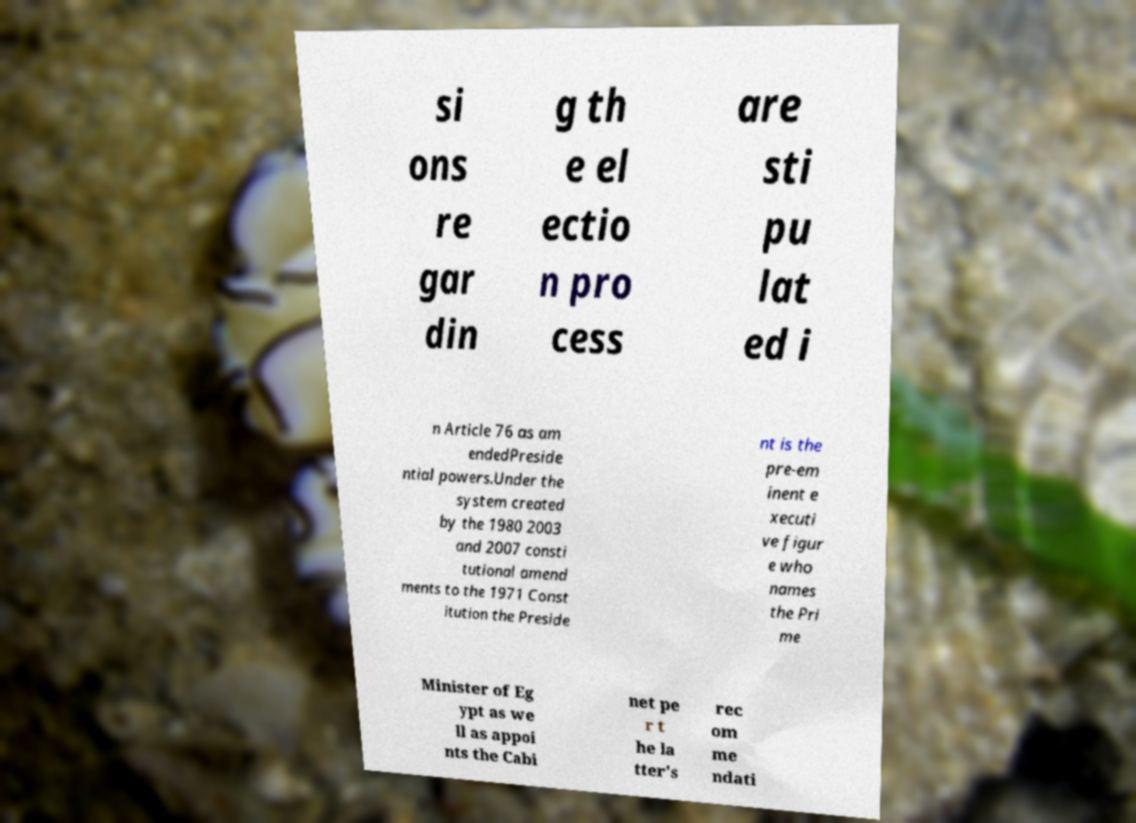For documentation purposes, I need the text within this image transcribed. Could you provide that? si ons re gar din g th e el ectio n pro cess are sti pu lat ed i n Article 76 as am endedPreside ntial powers.Under the system created by the 1980 2003 and 2007 consti tutional amend ments to the 1971 Const itution the Preside nt is the pre-em inent e xecuti ve figur e who names the Pri me Minister of Eg ypt as we ll as appoi nts the Cabi net pe r t he la tter's rec om me ndati 